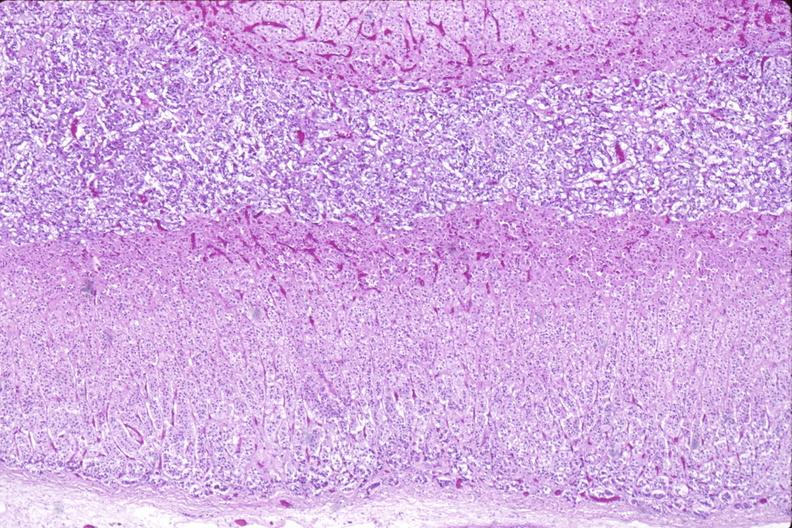what is present?
Answer the question using a single word or phrase. Endocrine 